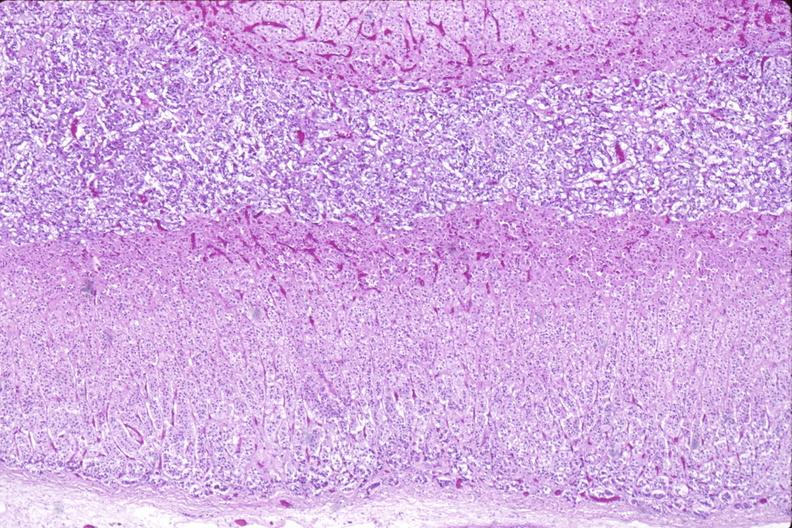what is present?
Answer the question using a single word or phrase. Endocrine 